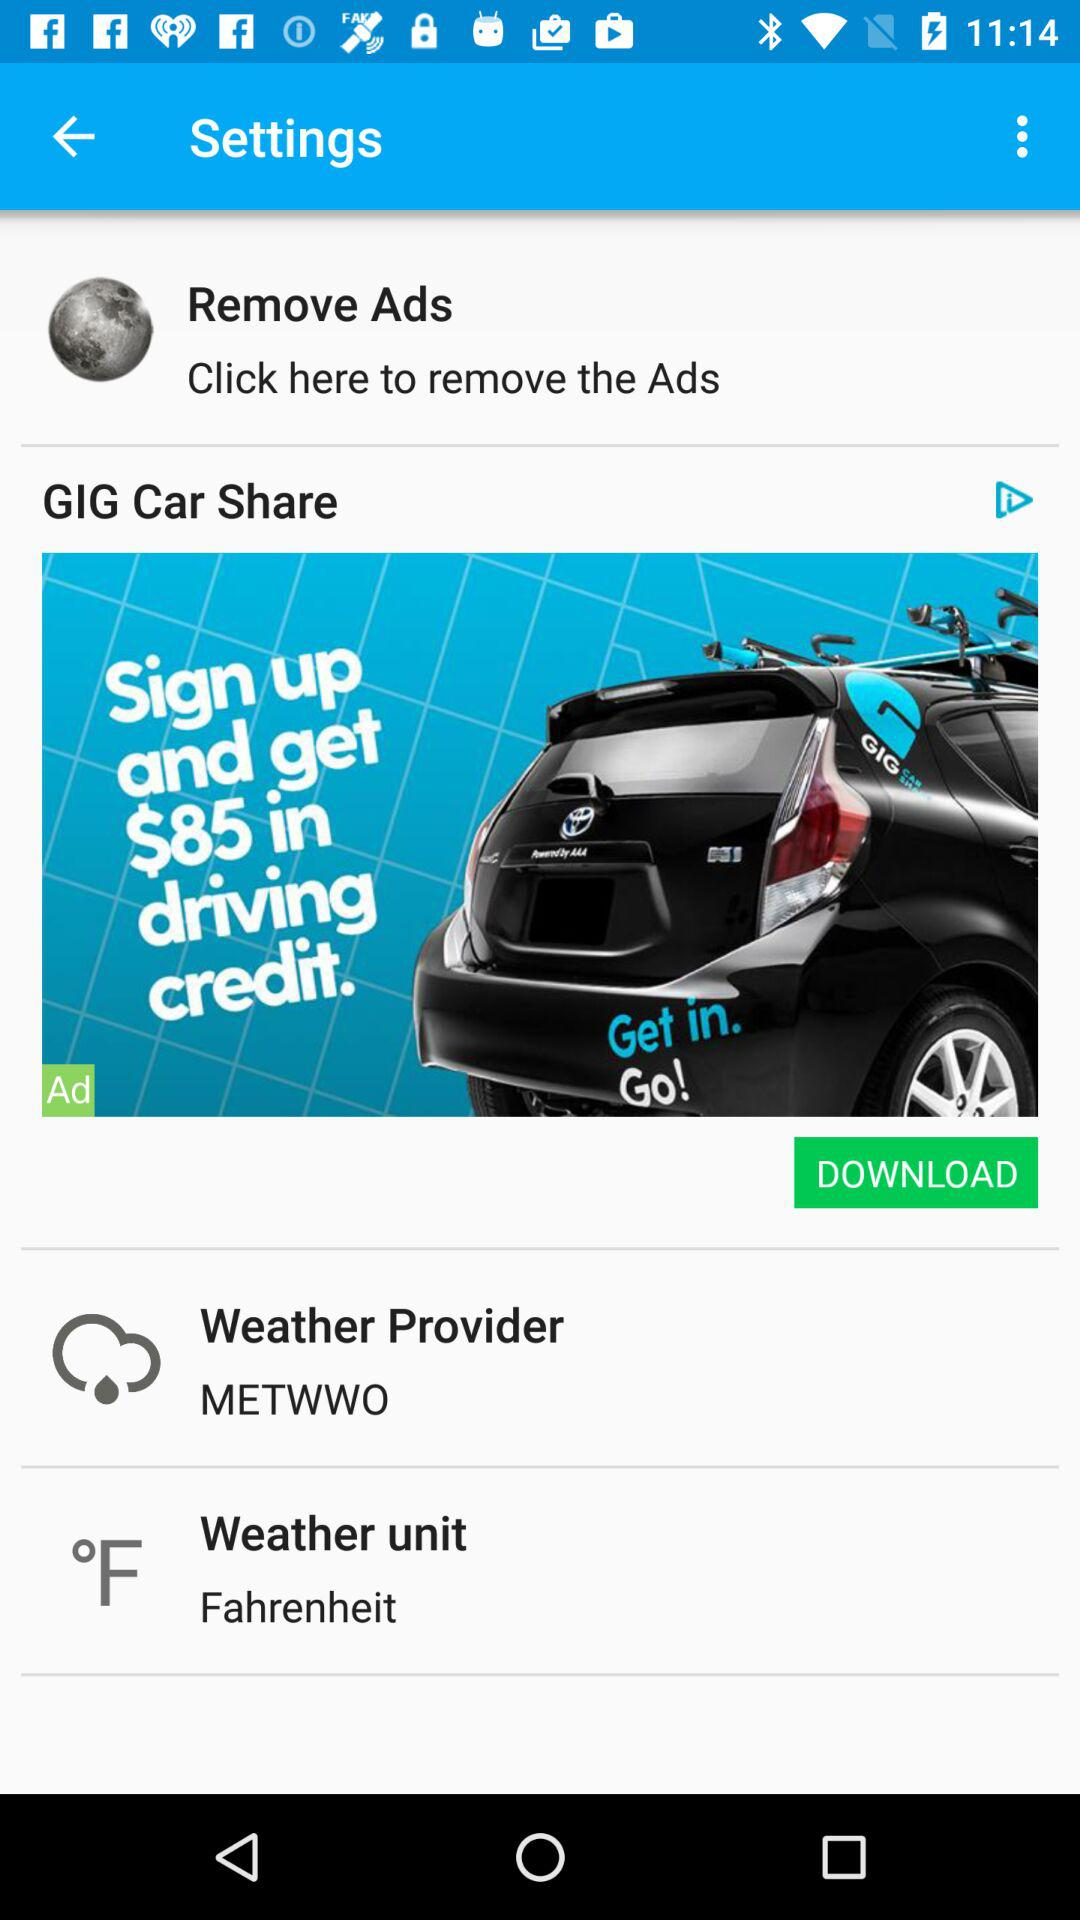What unit is the weather report in? The weather report is given in Fahrenheit. 